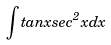Convert formula to latex. <formula><loc_0><loc_0><loc_500><loc_500>\int t a n x s e c ^ { 2 } x d x</formula> 